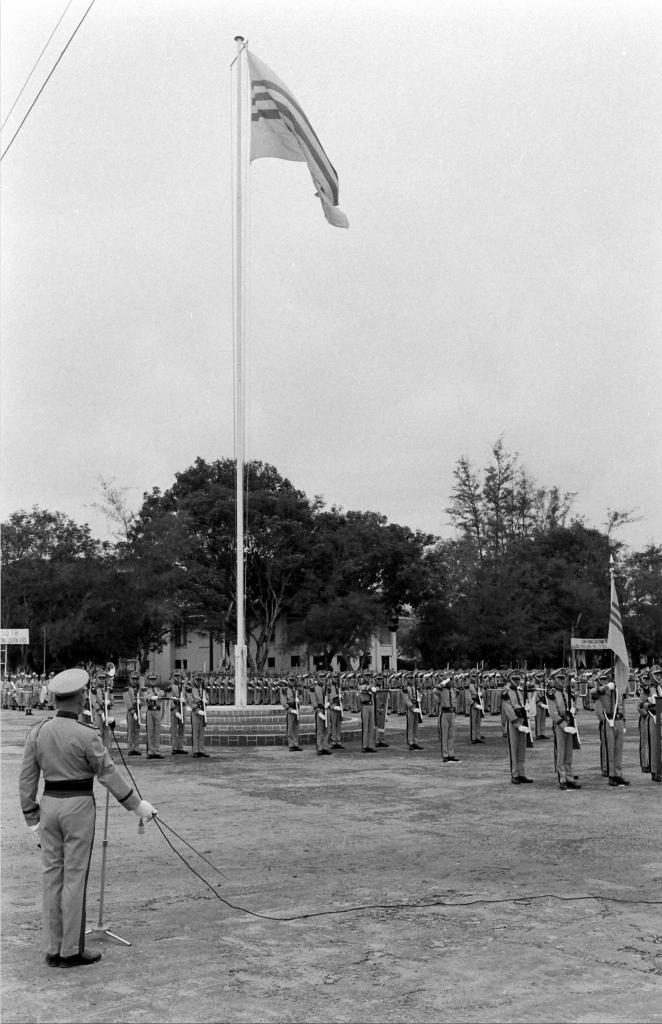What is the color scheme of the image? The image is black and white. Who or what can be seen in the image? There are people in the image. What object is present in the image that is typically used for displaying or supporting something? There is a pole in the image. What is attached to the pole in the image? There is a flag in the image. What is the flat, rectangular object in the image? There is a board in the image. What type of natural vegetation is visible in the image? There are trees in the image. What type of man-made structure is visible in the image? There is a building in the image. What part of the natural environment is visible in the background of the image? The sky is visible in the background of the image. What type of bells can be heard ringing in the image? There are no bells present in the image, and therefore no sound can be heard. 